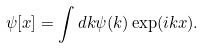<formula> <loc_0><loc_0><loc_500><loc_500>\psi [ x ] = \int d k \psi ( k ) \exp ( i k x ) .</formula> 